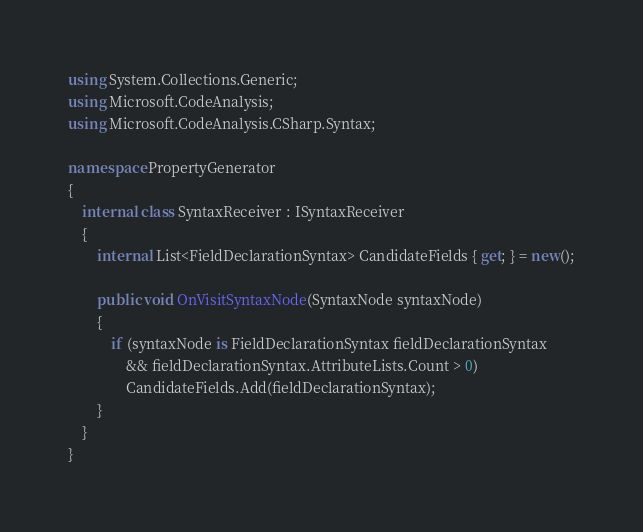Convert code to text. <code><loc_0><loc_0><loc_500><loc_500><_C#_>using System.Collections.Generic;
using Microsoft.CodeAnalysis;
using Microsoft.CodeAnalysis.CSharp.Syntax;

namespace PropertyGenerator
{
    internal class SyntaxReceiver : ISyntaxReceiver
    {
        internal List<FieldDeclarationSyntax> CandidateFields { get; } = new();

        public void OnVisitSyntaxNode(SyntaxNode syntaxNode)
        {
            if (syntaxNode is FieldDeclarationSyntax fieldDeclarationSyntax
                && fieldDeclarationSyntax.AttributeLists.Count > 0)
                CandidateFields.Add(fieldDeclarationSyntax);
        }
    }
}</code> 